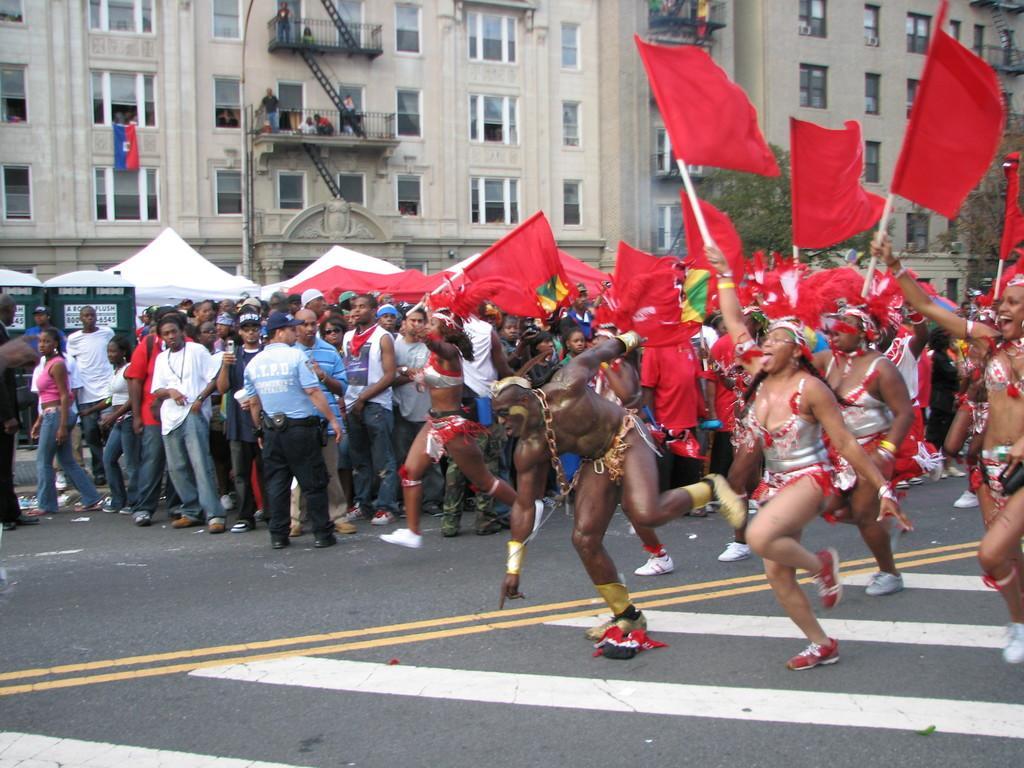Describe this image in one or two sentences. To the right side of the image there are few people dancing on the road and also there are wearing costumes and holding the red flags in their hands. Behind them there are many people standing on the road and also there are white color tint. And in the background there is a building with glass windows, walls, pillars and balconies. 